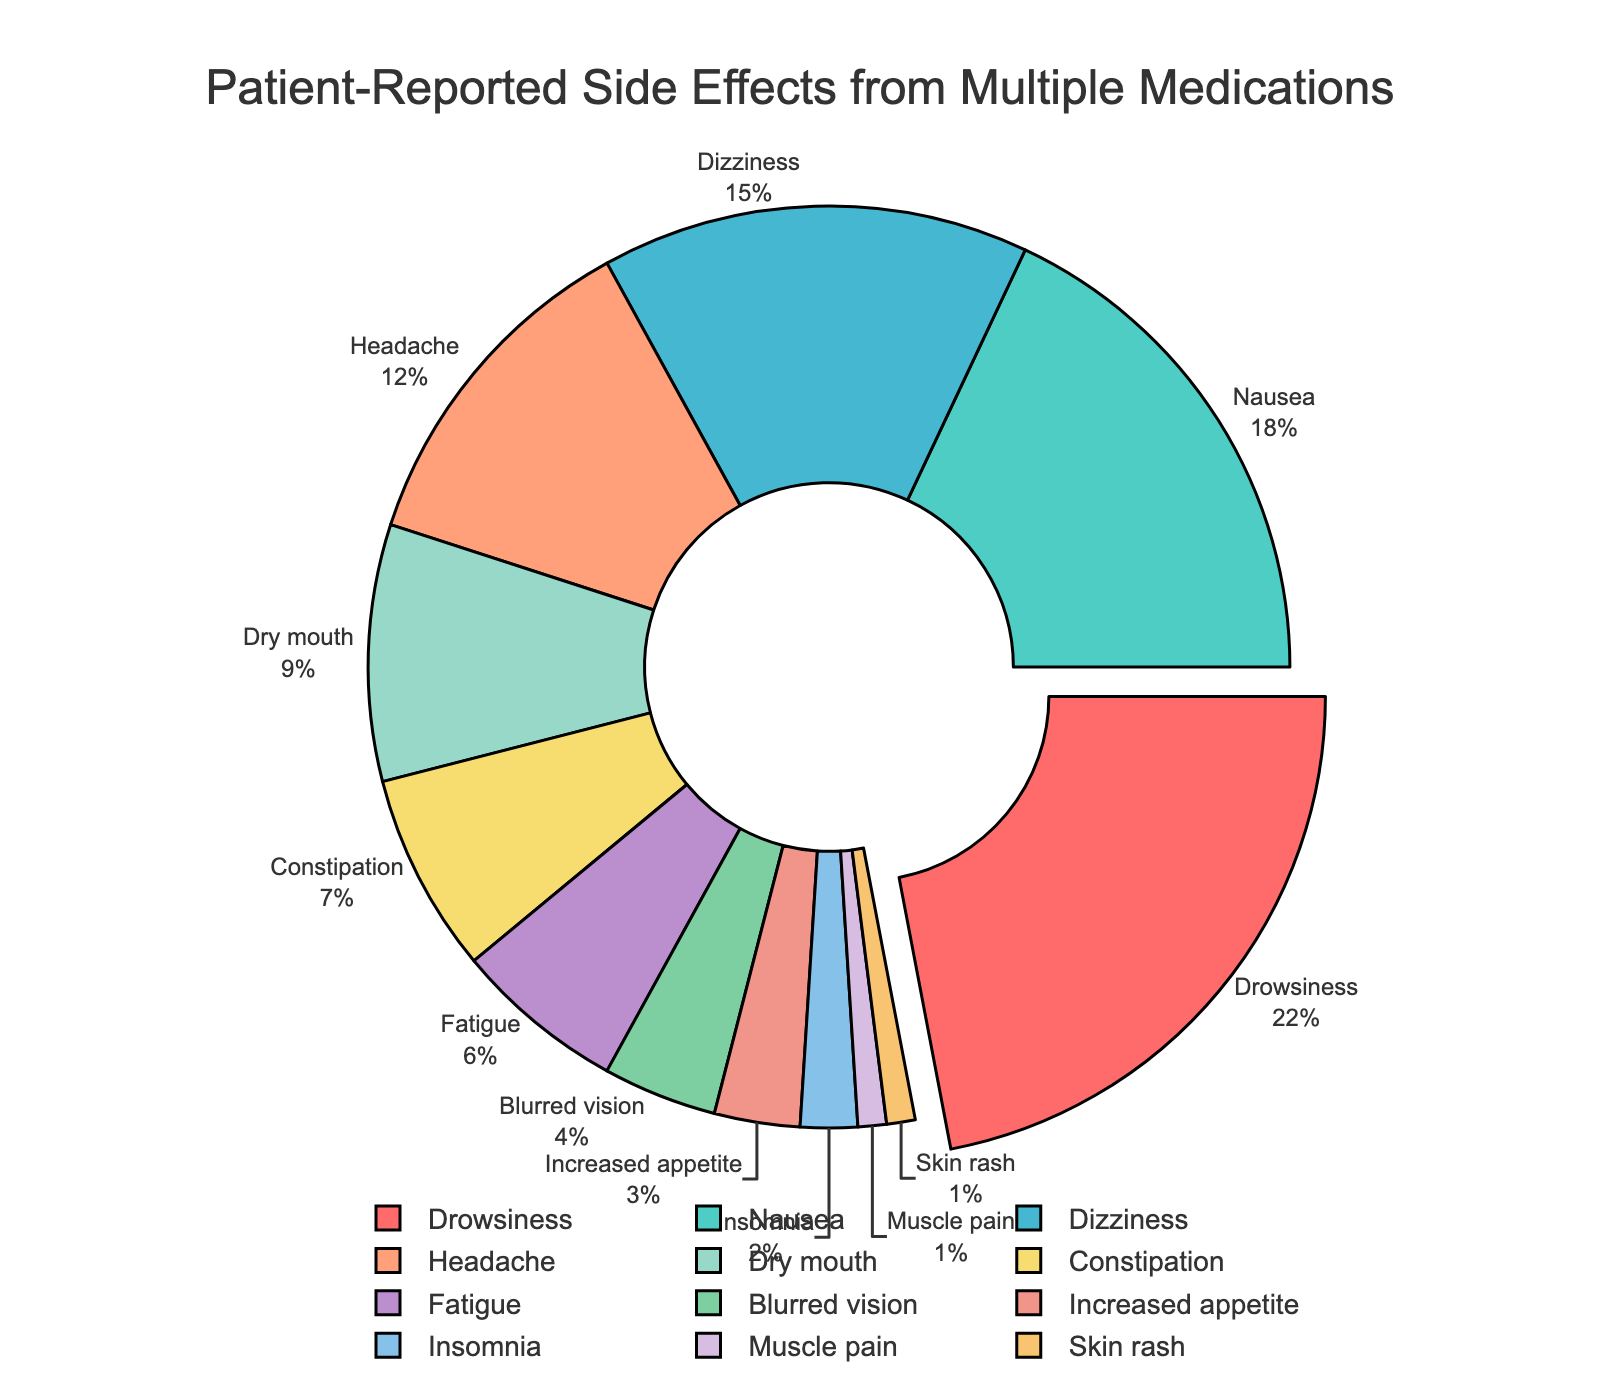Which side effect has the highest percentage? The figure shows a pie chart where the side effects are represented with different sections. The section that is slightly pulled out from the rest represents the highest percentage. This section is labeled "Drowsiness" with 22%.
Answer: Drowsiness Which side effects are reported by less than 5% of patients? To identify side effects reported by less than 5% of patients, observe the sections of the pie chart that are labeled with percentages lower than 5%. These sections are "Blurred vision," "Increased appetite," "Insomnia," "Muscle pain," and "Skin rash."
Answer: Blurred vision, Increased appetite, Insomnia, Muscle pain, Skin rash What is the combined percentage of patients reporting Drowsiness and Nausea? Add the percentages for Drowsiness and Nausea. Drowsiness is 22% and Nausea is 18%. Therefore, 22% + 18% = 40%.
Answer: 40% Which side effect is the least reported and what percentage of patients report it? Look at the smallest sections in the pie chart and find the one with the smallest percentage. Both "Muscle pain" and "Skin rash" are reported by 1% of patients.
Answer: Muscle pain, Skin rash - 1% How many side effects are reported by more than 10% of patients? Count the sections of the pie chart with percentages greater than 10%. These are Drowsiness (22%), Nausea (18%), Dizziness (15%), and Headache (12%). There are 4 such side effects.
Answer: 4 Which side effect has a percentage closest to 10%? Observe the percentage values around 10%. The side effect "Dry mouth" has a percentage of 9%, which is closest to 10%.
Answer: Dry mouth How does the percentage of patients reporting Constipation compare to those reporting Fatigue? Compare the sections labeled "Constipation" and "Fatigue." Constipation is reported by 7% of patients and Fatigue by 6%. So, Constipation is reported by a slightly higher percentage of patients.
Answer: Constipation > Fatigue Which section is colored red and what side effect does it represent? Identify the section in the pie chart colored red. This section represents "Drowsiness."
Answer: Drowsiness What percentage of patients report either Dry mouth or Increased appetite? Add the percentages for Dry mouth and Increased appetite. Dry mouth is reported by 9% and Increased appetite by 3%. Therefore, 9% + 3% = 12%.
Answer: 12% Compare the total percentage of patients reporting Blurred vision, Insomnia, Muscle pain, and Skin rash. Add the percentages of Blurred vision (4%), Insomnia (2%), Muscle pain (1%), and Skin rash (1%). Therefore, 4% + 2% + 1% + 1% = 8%.
Answer: 8% 